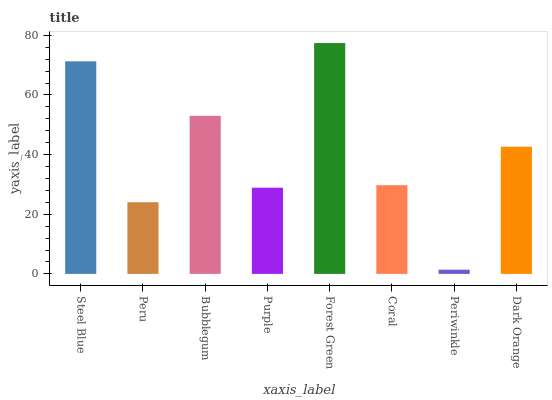Is Peru the minimum?
Answer yes or no. No. Is Peru the maximum?
Answer yes or no. No. Is Steel Blue greater than Peru?
Answer yes or no. Yes. Is Peru less than Steel Blue?
Answer yes or no. Yes. Is Peru greater than Steel Blue?
Answer yes or no. No. Is Steel Blue less than Peru?
Answer yes or no. No. Is Dark Orange the high median?
Answer yes or no. Yes. Is Coral the low median?
Answer yes or no. Yes. Is Periwinkle the high median?
Answer yes or no. No. Is Purple the low median?
Answer yes or no. No. 